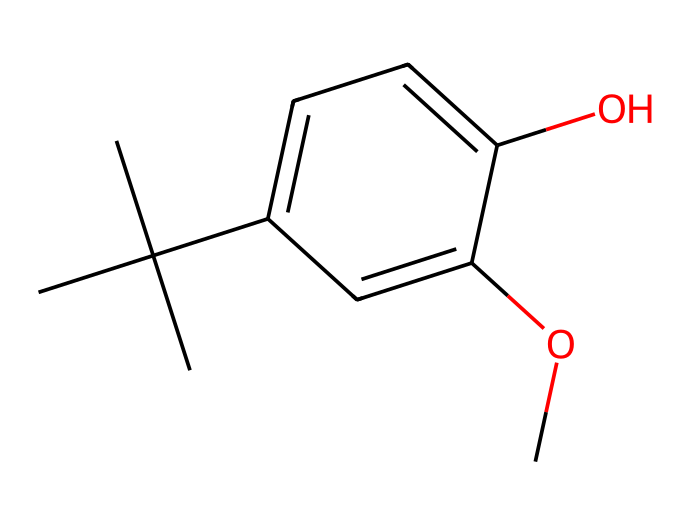What is the total number of carbon atoms in butylated hydroxyanisole (BHA)? The SMILES structure shows multiple carbon atoms (C). Counting them in the structure reveals that there are 10 carbon atoms in total.
Answer: 10 How many hydroxyl (–OH) groups are present in this molecule? In the provided SMILES, there is a distinct "O" connected to a carbon atom indicating a hydroxyl group, and upon inspection, there is only one –OH group present.
Answer: 1 What functional group is indicated by the presence of "O" in the structure? The presence of "O" linked to an H indicates a hydroxyl functional group, which is characteristic of phenolic compounds like BHA.
Answer: hydroxyl What is the molecular formula of butylated hydroxyanisole (BHA)? By analyzing the structural SMILES, we determine the counts of carbon (C), hydrogen (H), and oxygen (O) atoms: C10, H14, O2 gives the molecular formula of BHA.
Answer: C10H14O2 Is butylated hydroxyanisole (BHA) classified as a synthetic antioxidant? BHA is considered a synthetic antioxidant commonly used to prevent rancidity in fats and oils in food packaging, thus fitting the classification.
Answer: yes How does the structure contribute to the stability of BHA as an antioxidant? The structure features a phenolic –OH group and a tert-butyl group, which stabilizes free radicals, making BHA effective in preventing lipid oxidation.
Answer: stabilizes free radicals 